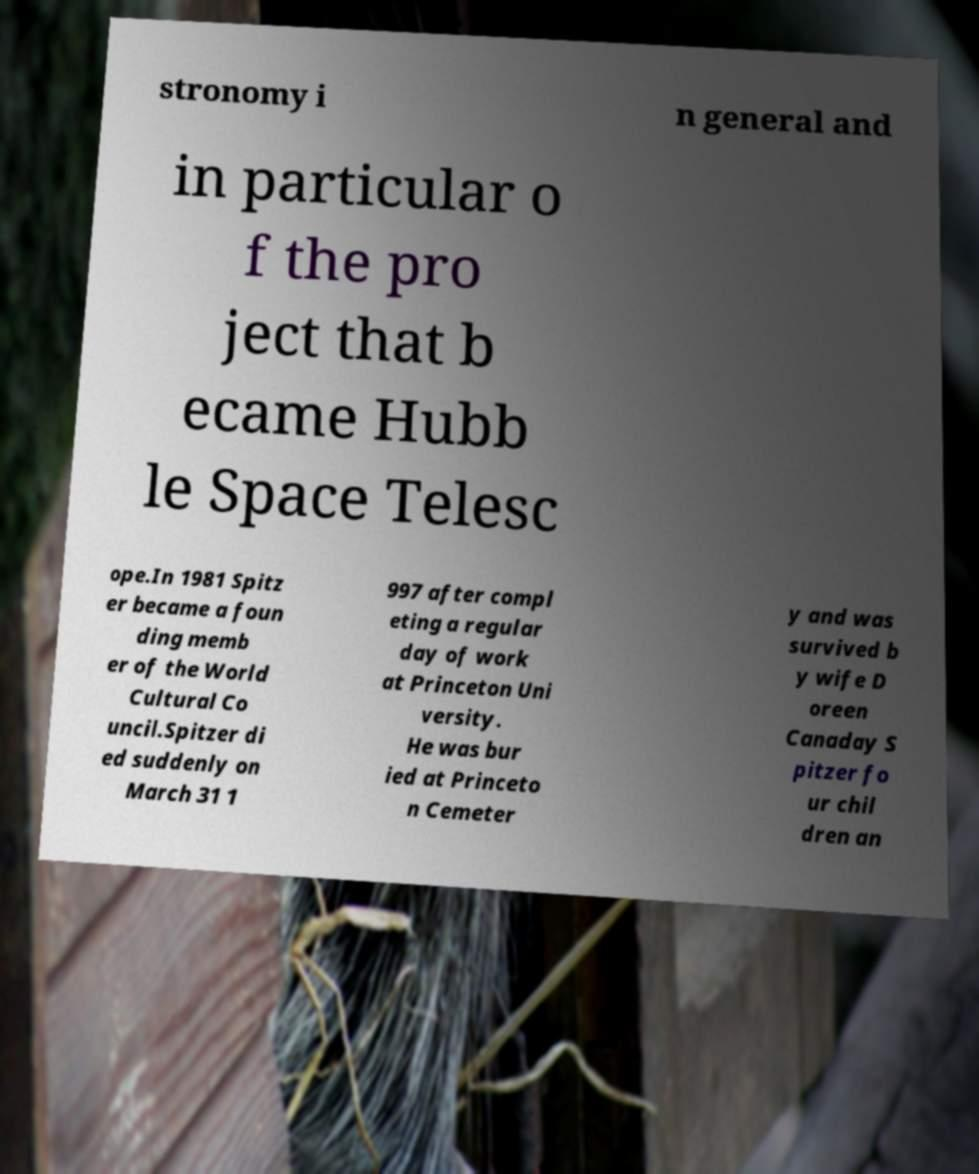What messages or text are displayed in this image? I need them in a readable, typed format. stronomy i n general and in particular o f the pro ject that b ecame Hubb le Space Telesc ope.In 1981 Spitz er became a foun ding memb er of the World Cultural Co uncil.Spitzer di ed suddenly on March 31 1 997 after compl eting a regular day of work at Princeton Uni versity. He was bur ied at Princeto n Cemeter y and was survived b y wife D oreen Canaday S pitzer fo ur chil dren an 